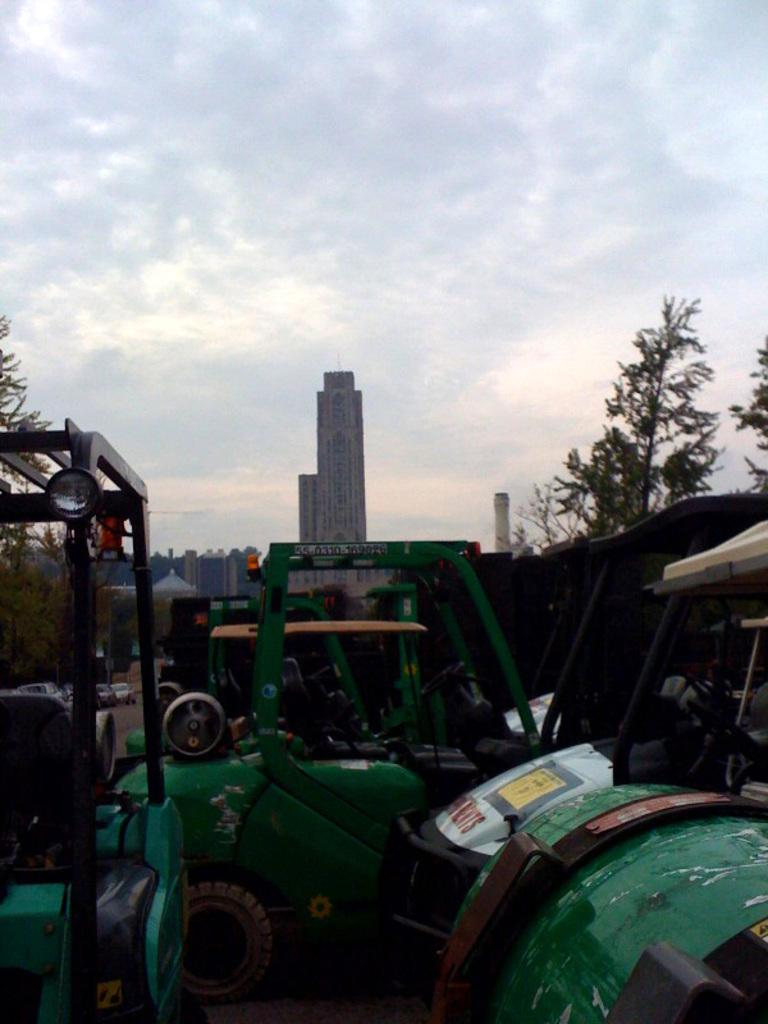What types of objects can be seen in the image? There are vehicles in the image. What can be seen in the background behind the vehicles? There are buildings behind the vehicles. What type of natural elements are present in the image? There are trees in the image. What is visible in the sky in the image? There are clouds visible in the image. What language is being spoken by the trees in the image? Trees do not speak any language, so this cannot be determined from the image. 